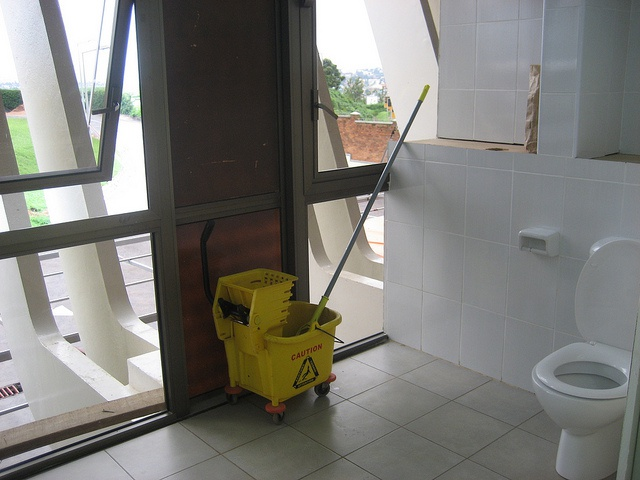Describe the objects in this image and their specific colors. I can see a toilet in white and gray tones in this image. 